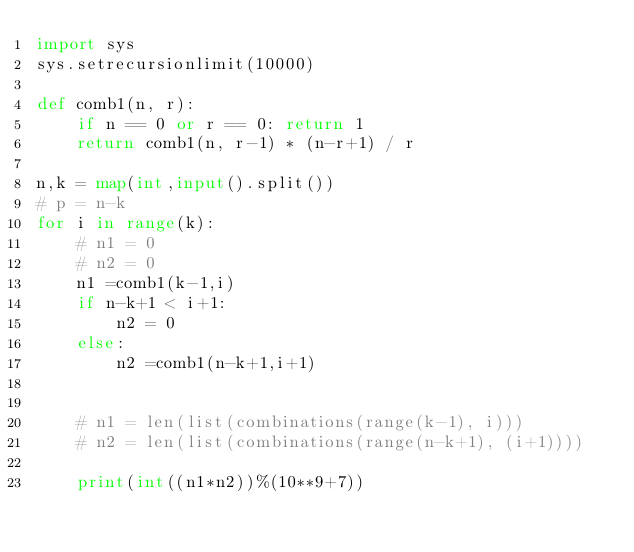<code> <loc_0><loc_0><loc_500><loc_500><_Python_>import sys
sys.setrecursionlimit(10000)

def comb1(n, r):
    if n == 0 or r == 0: return 1
    return comb1(n, r-1) * (n-r+1) / r 

n,k = map(int,input().split())
# p = n-k
for i in range(k):
	# n1 = 0
	# n2 = 0
	n1 =comb1(k-1,i)
	if n-k+1 < i+1:
		n2 = 0
	else:
		n2 =comb1(n-k+1,i+1)


	# n1 = len(list(combinations(range(k-1), i)))
	# n2 = len(list(combinations(range(n-k+1), (i+1))))

	print(int((n1*n2))%(10**9+7))</code> 